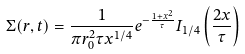Convert formula to latex. <formula><loc_0><loc_0><loc_500><loc_500>\Sigma ( r , t ) = \frac { 1 } { \pi r _ { 0 } ^ { 2 } \tau x ^ { 1 / 4 } } e ^ { - \frac { 1 + x ^ { 2 } } { \tau } } I _ { 1 / 4 } \left ( \frac { 2 x } { \tau } \right )</formula> 